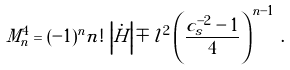Convert formula to latex. <formula><loc_0><loc_0><loc_500><loc_500>M _ { n } ^ { 4 } = ( - 1 ) ^ { n } n ! \, \left | \dot { H } \right | \mp l ^ { 2 } \left ( \frac { c _ { s } ^ { - 2 } - 1 } { 4 } \right ) ^ { n - 1 } \, .</formula> 